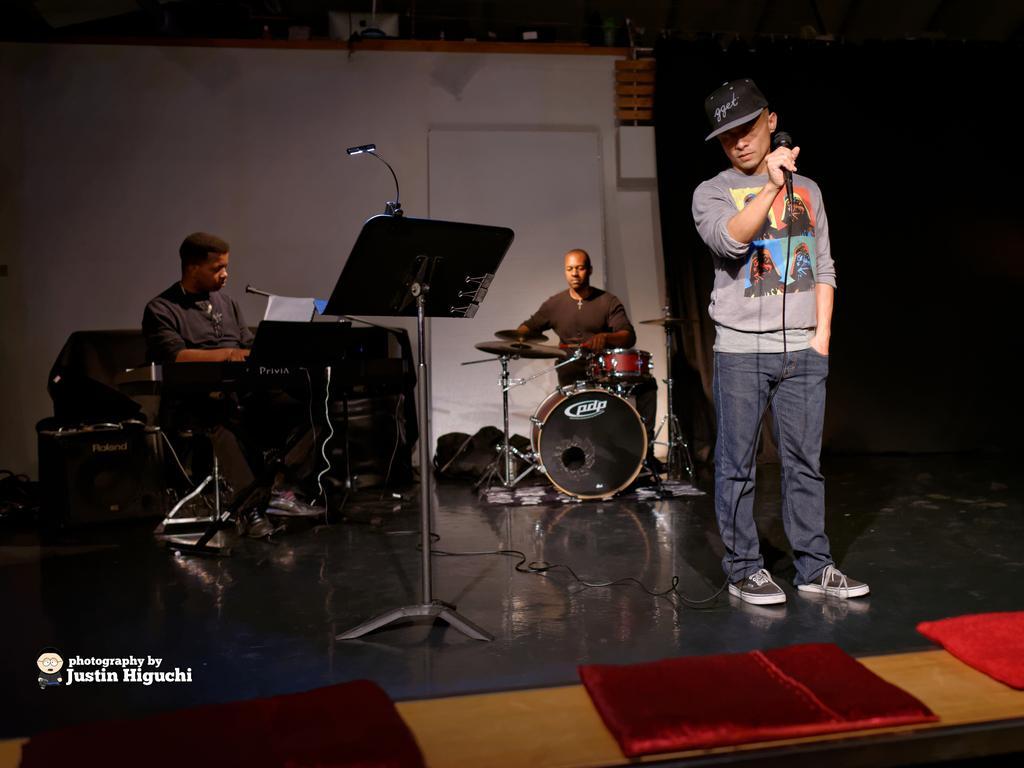Can you describe this image briefly? In this image I can see three man where two of them are sitting and one is standing and holding a mic. I can also see a drum set and a stand. 